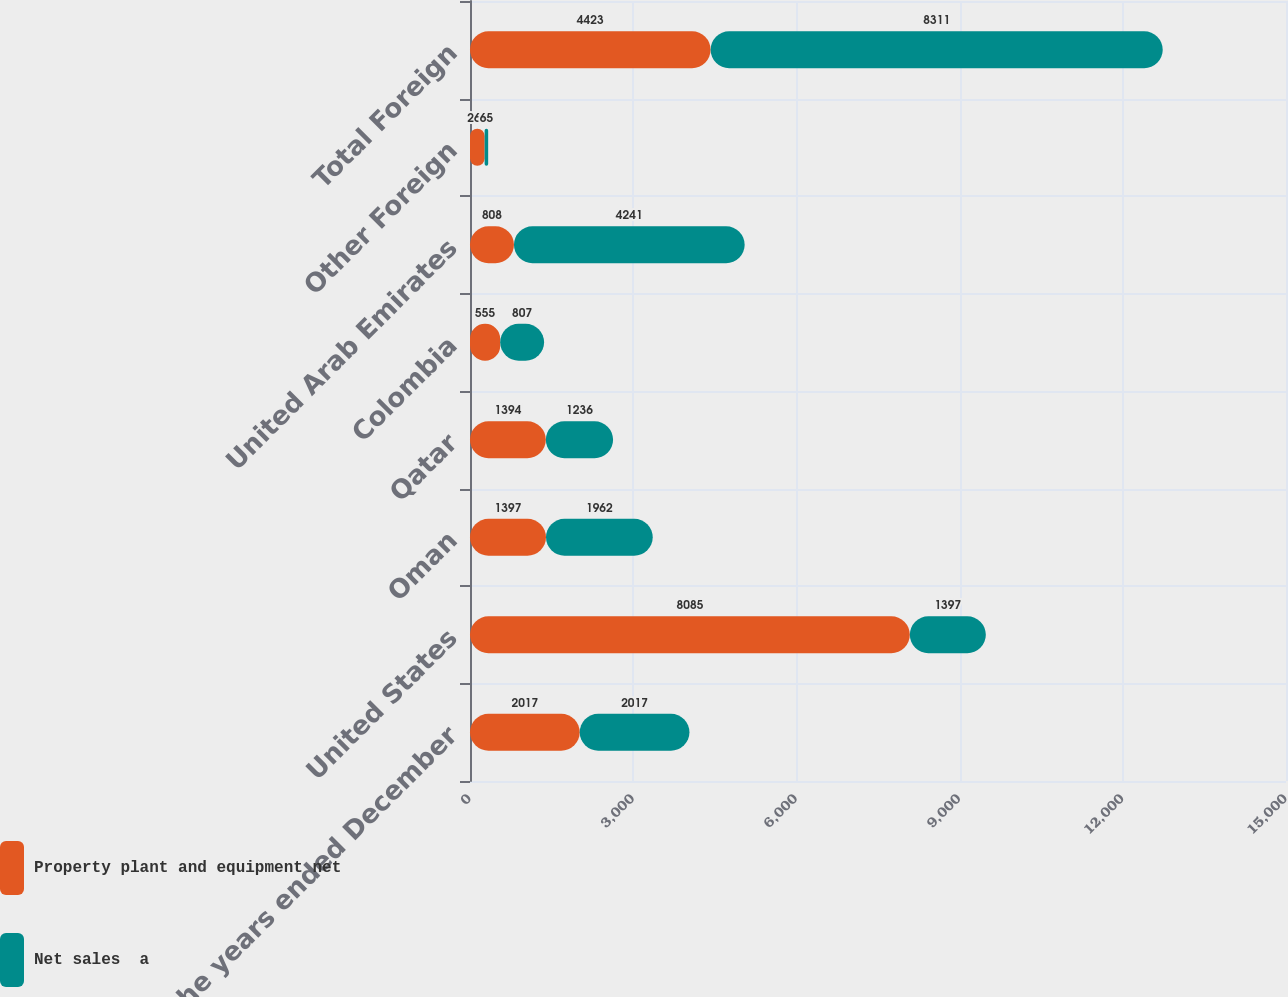Convert chart. <chart><loc_0><loc_0><loc_500><loc_500><stacked_bar_chart><ecel><fcel>For the years ended December<fcel>United States<fcel>Oman<fcel>Qatar<fcel>Colombia<fcel>United Arab Emirates<fcel>Other Foreign<fcel>Total Foreign<nl><fcel>Property plant and equipment net<fcel>2017<fcel>8085<fcel>1397<fcel>1394<fcel>555<fcel>808<fcel>269<fcel>4423<nl><fcel>Net sales  a<fcel>2017<fcel>1397<fcel>1962<fcel>1236<fcel>807<fcel>4241<fcel>65<fcel>8311<nl></chart> 